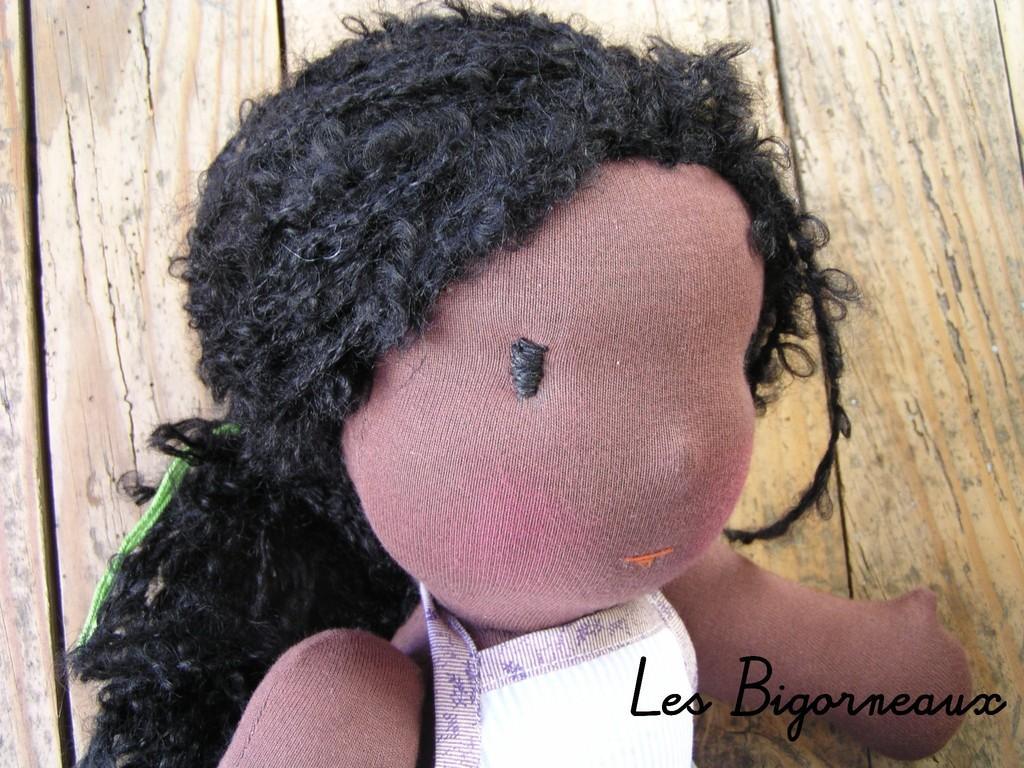In one or two sentences, can you explain what this image depicts? In the image we can see there is a doll. 